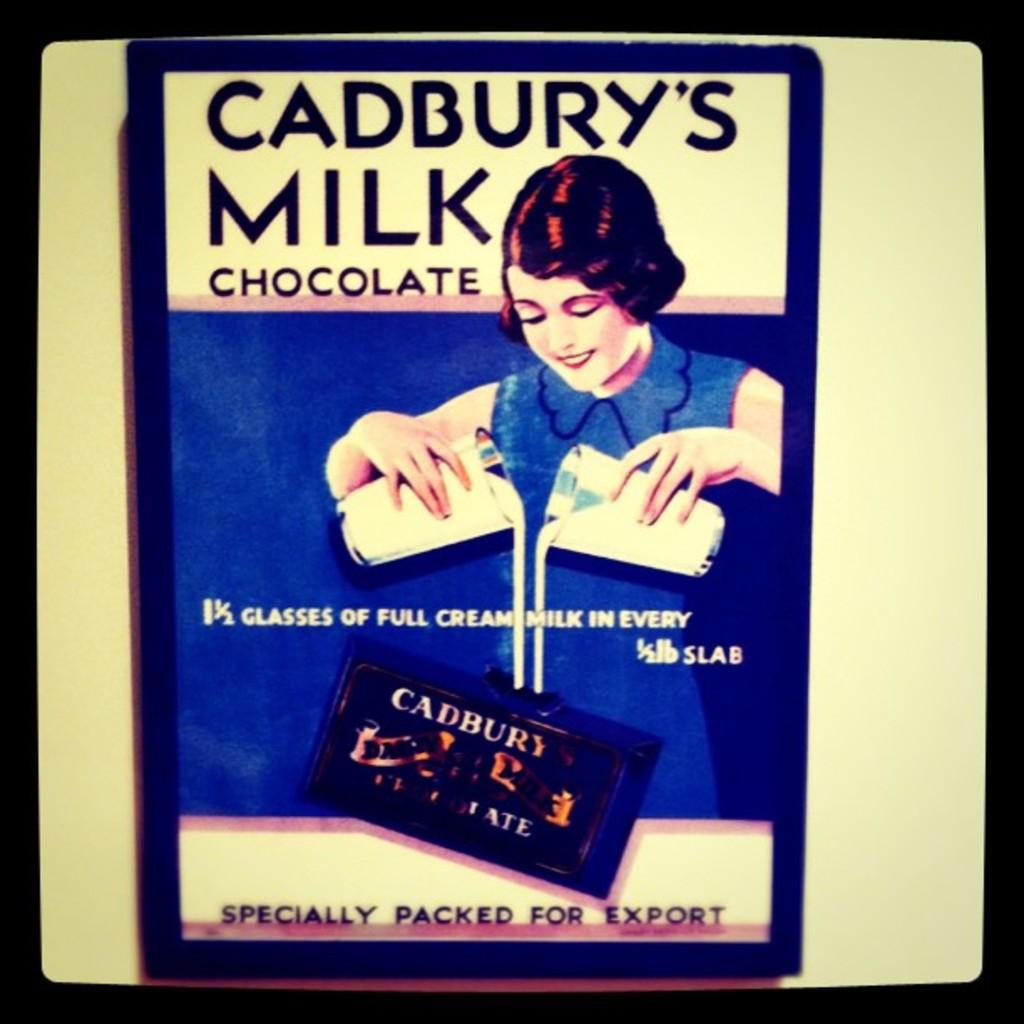Provide a one-sentence caption for the provided image. An old advertisement for Cadbury's Milk featuring a woman. 